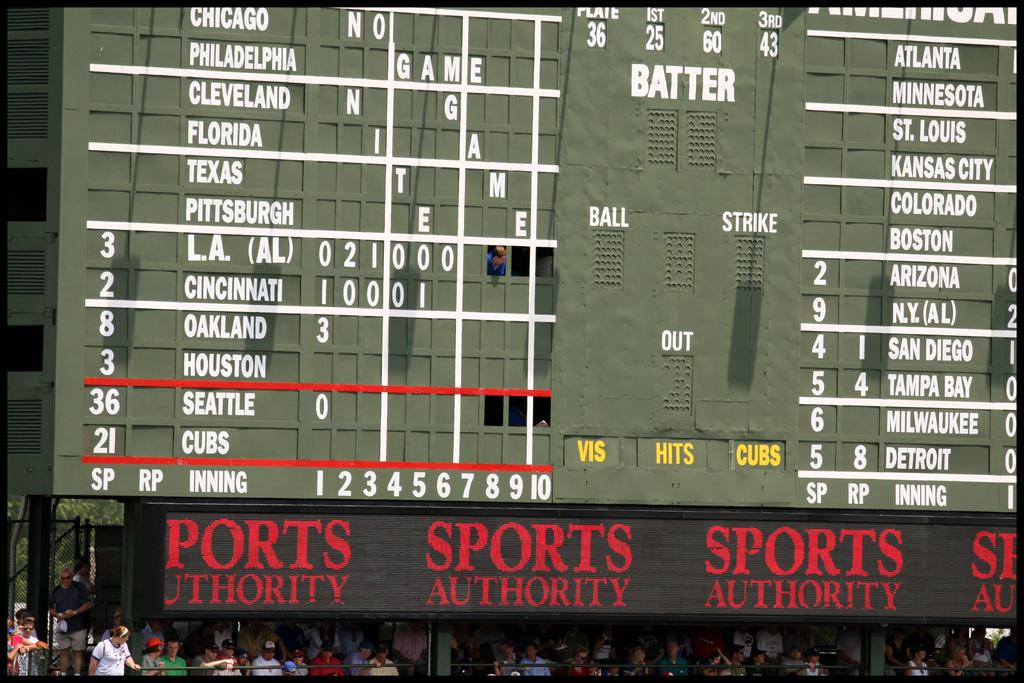<image>
Write a terse but informative summary of the picture. A sign in a ball field showing baseball games with Sports Authority at the bottom 